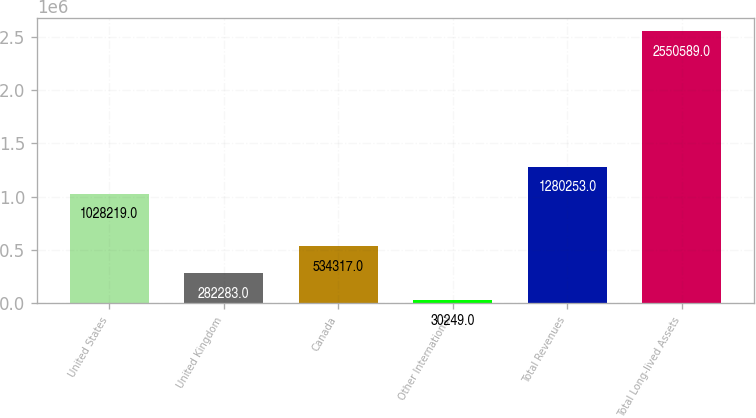Convert chart to OTSL. <chart><loc_0><loc_0><loc_500><loc_500><bar_chart><fcel>United States<fcel>United Kingdom<fcel>Canada<fcel>Other International<fcel>Total Revenues<fcel>Total Long-lived Assets<nl><fcel>1.02822e+06<fcel>282283<fcel>534317<fcel>30249<fcel>1.28025e+06<fcel>2.55059e+06<nl></chart> 